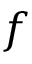Convert formula to latex. <formula><loc_0><loc_0><loc_500><loc_500>f</formula> 